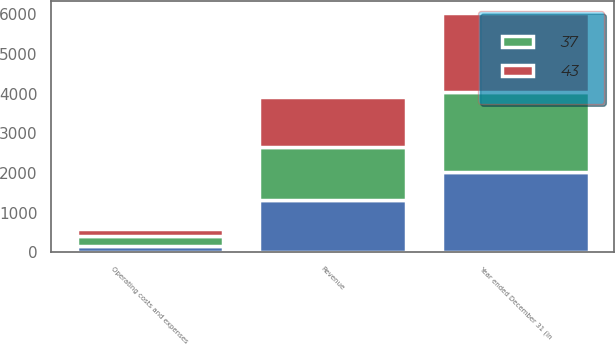Convert chart to OTSL. <chart><loc_0><loc_0><loc_500><loc_500><stacked_bar_chart><ecel><fcel>Year ended December 31 (in<fcel>Revenue<fcel>Operating costs and expenses<nl><fcel>37<fcel>2015<fcel>1349<fcel>246<nl><fcel>nan<fcel>2014<fcel>1315<fcel>162<nl><fcel>43<fcel>2013<fcel>1262<fcel>190<nl></chart> 